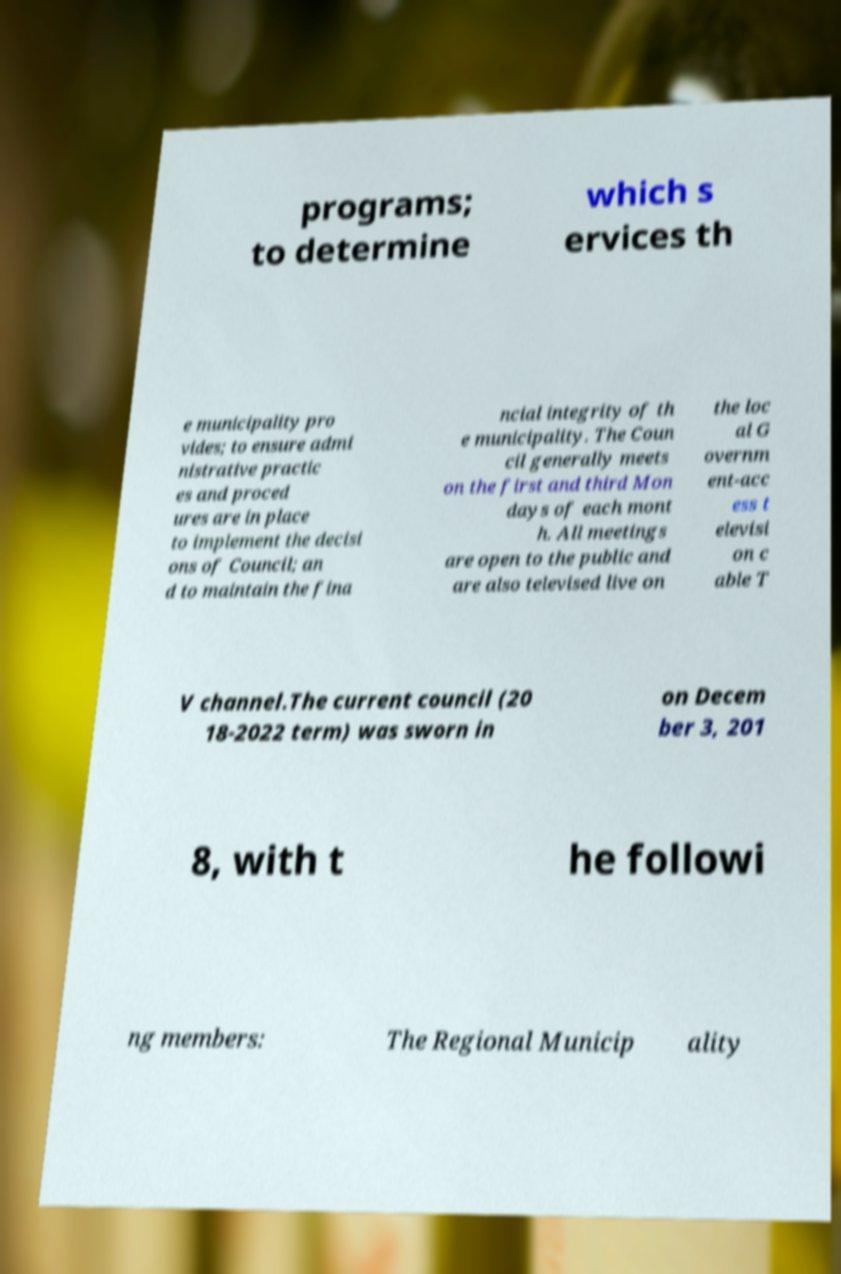I need the written content from this picture converted into text. Can you do that? programs; to determine which s ervices th e municipality pro vides; to ensure admi nistrative practic es and proced ures are in place to implement the decisi ons of Council; an d to maintain the fina ncial integrity of th e municipality. The Coun cil generally meets on the first and third Mon days of each mont h. All meetings are open to the public and are also televised live on the loc al G overnm ent-acc ess t elevisi on c able T V channel.The current council (20 18-2022 term) was sworn in on Decem ber 3, 201 8, with t he followi ng members: The Regional Municip ality 